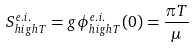<formula> <loc_0><loc_0><loc_500><loc_500>S _ { h i g h T } ^ { e . i . } = g \phi _ { h i g h T } ^ { e . i . } ( 0 ) = \frac { \pi T } { \mu }</formula> 